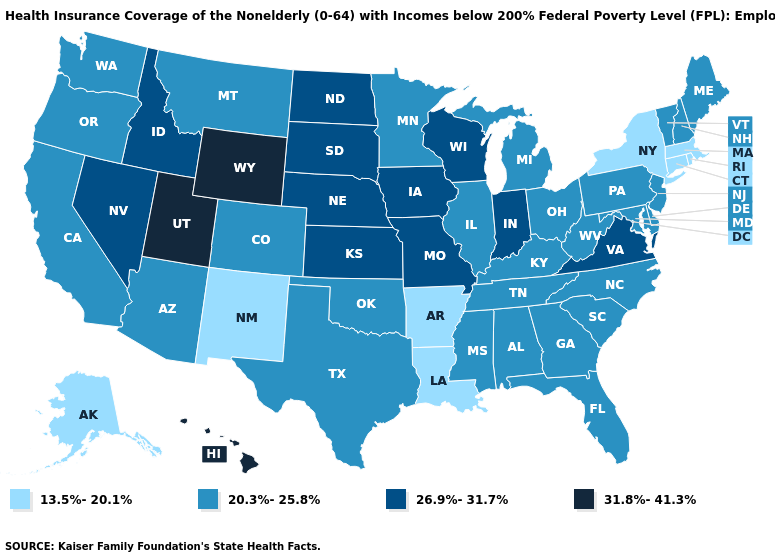Among the states that border North Dakota , does Minnesota have the highest value?
Quick response, please. No. What is the lowest value in the USA?
Answer briefly. 13.5%-20.1%. What is the value of Louisiana?
Write a very short answer. 13.5%-20.1%. What is the value of South Dakota?
Be succinct. 26.9%-31.7%. Which states have the lowest value in the MidWest?
Write a very short answer. Illinois, Michigan, Minnesota, Ohio. Name the states that have a value in the range 13.5%-20.1%?
Write a very short answer. Alaska, Arkansas, Connecticut, Louisiana, Massachusetts, New Mexico, New York, Rhode Island. Does Utah have the same value as Hawaii?
Keep it brief. Yes. Does Connecticut have the lowest value in the USA?
Concise answer only. Yes. Which states have the lowest value in the South?
Answer briefly. Arkansas, Louisiana. What is the value of Texas?
Keep it brief. 20.3%-25.8%. What is the value of Missouri?
Give a very brief answer. 26.9%-31.7%. What is the value of Louisiana?
Write a very short answer. 13.5%-20.1%. What is the highest value in states that border Maine?
Concise answer only. 20.3%-25.8%. Does Nebraska have a higher value than Massachusetts?
Keep it brief. Yes. Name the states that have a value in the range 20.3%-25.8%?
Short answer required. Alabama, Arizona, California, Colorado, Delaware, Florida, Georgia, Illinois, Kentucky, Maine, Maryland, Michigan, Minnesota, Mississippi, Montana, New Hampshire, New Jersey, North Carolina, Ohio, Oklahoma, Oregon, Pennsylvania, South Carolina, Tennessee, Texas, Vermont, Washington, West Virginia. 